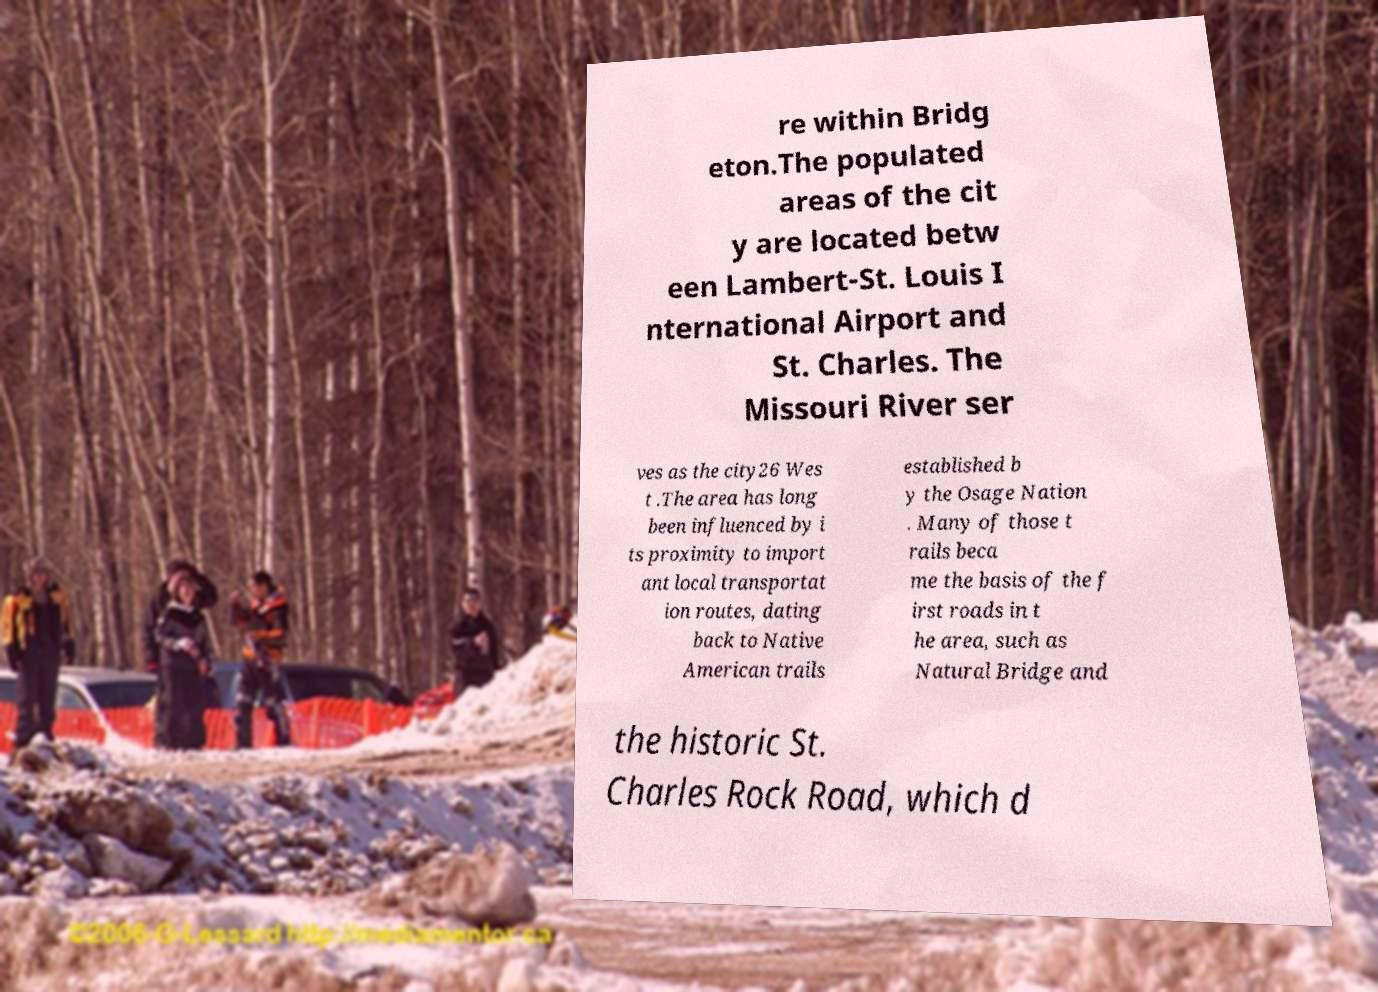Could you assist in decoding the text presented in this image and type it out clearly? re within Bridg eton.The populated areas of the cit y are located betw een Lambert-St. Louis I nternational Airport and St. Charles. The Missouri River ser ves as the city26 Wes t .The area has long been influenced by i ts proximity to import ant local transportat ion routes, dating back to Native American trails established b y the Osage Nation . Many of those t rails beca me the basis of the f irst roads in t he area, such as Natural Bridge and the historic St. Charles Rock Road, which d 